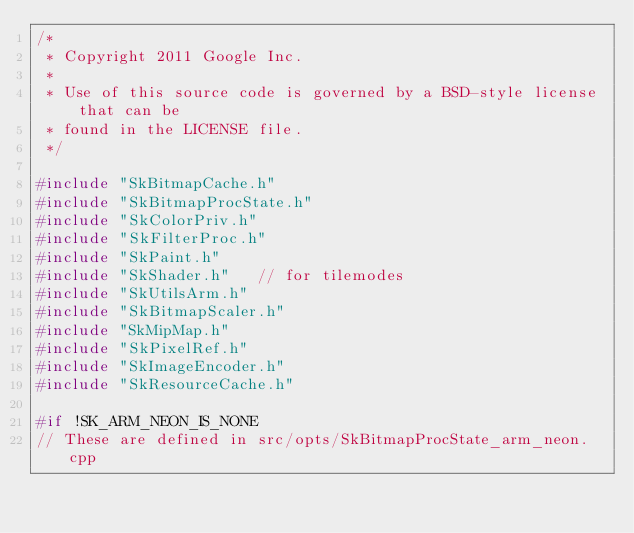Convert code to text. <code><loc_0><loc_0><loc_500><loc_500><_C++_>/*
 * Copyright 2011 Google Inc.
 *
 * Use of this source code is governed by a BSD-style license that can be
 * found in the LICENSE file.
 */

#include "SkBitmapCache.h"
#include "SkBitmapProcState.h"
#include "SkColorPriv.h"
#include "SkFilterProc.h"
#include "SkPaint.h"
#include "SkShader.h"   // for tilemodes
#include "SkUtilsArm.h"
#include "SkBitmapScaler.h"
#include "SkMipMap.h"
#include "SkPixelRef.h"
#include "SkImageEncoder.h"
#include "SkResourceCache.h"

#if !SK_ARM_NEON_IS_NONE
// These are defined in src/opts/SkBitmapProcState_arm_neon.cpp</code> 